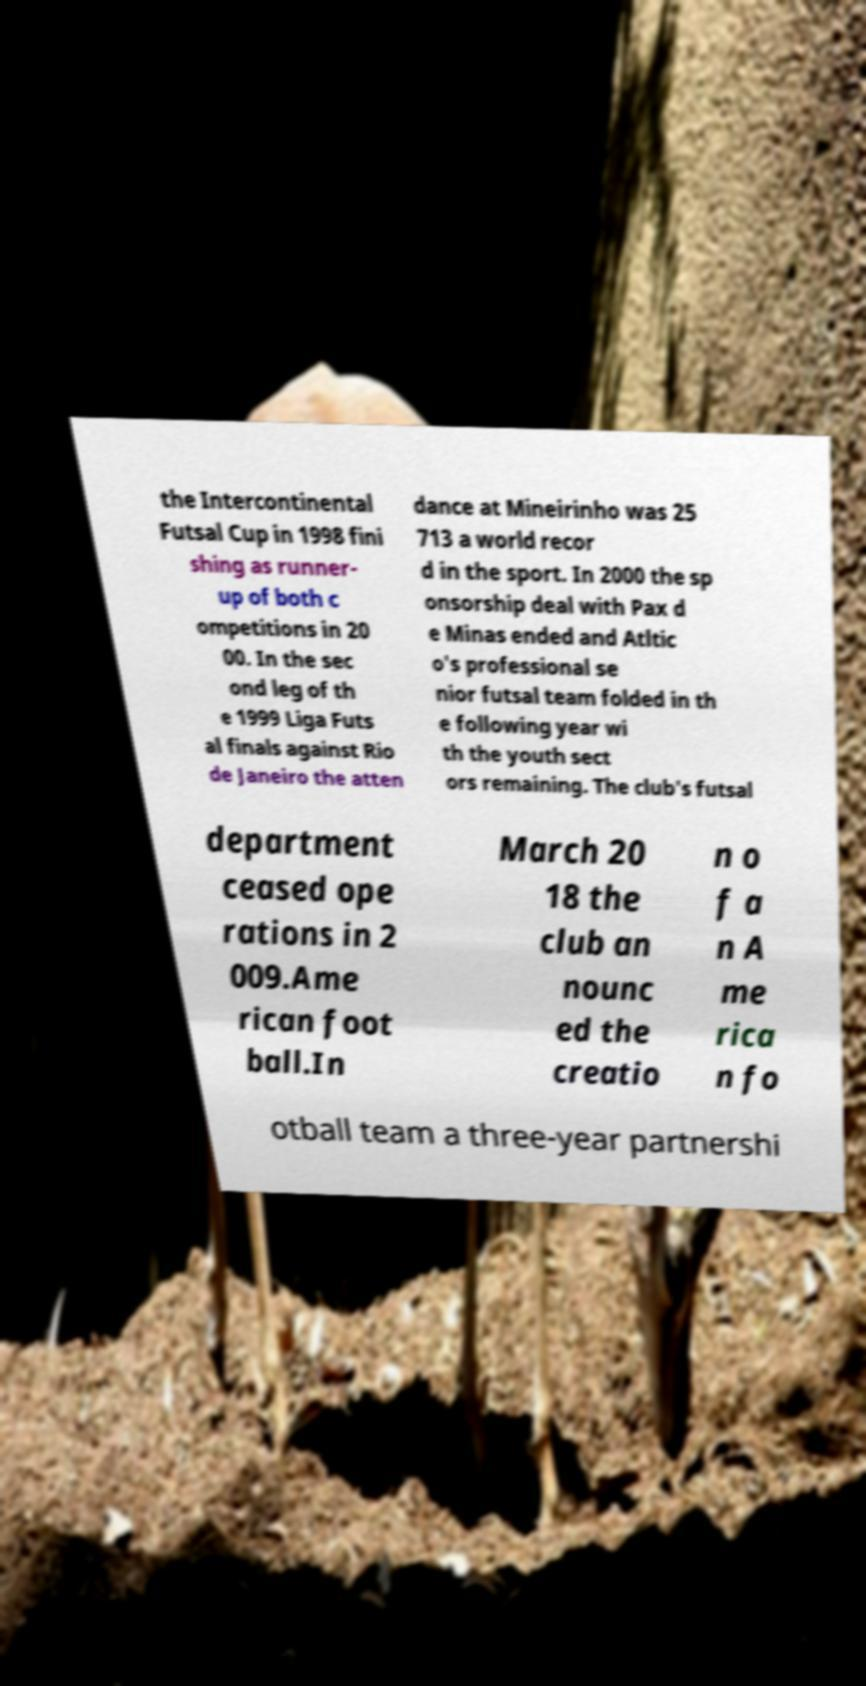Please identify and transcribe the text found in this image. the Intercontinental Futsal Cup in 1998 fini shing as runner- up of both c ompetitions in 20 00. In the sec ond leg of th e 1999 Liga Futs al finals against Rio de Janeiro the atten dance at Mineirinho was 25 713 a world recor d in the sport. In 2000 the sp onsorship deal with Pax d e Minas ended and Atltic o's professional se nior futsal team folded in th e following year wi th the youth sect ors remaining. The club's futsal department ceased ope rations in 2 009.Ame rican foot ball.In March 20 18 the club an nounc ed the creatio n o f a n A me rica n fo otball team a three-year partnershi 